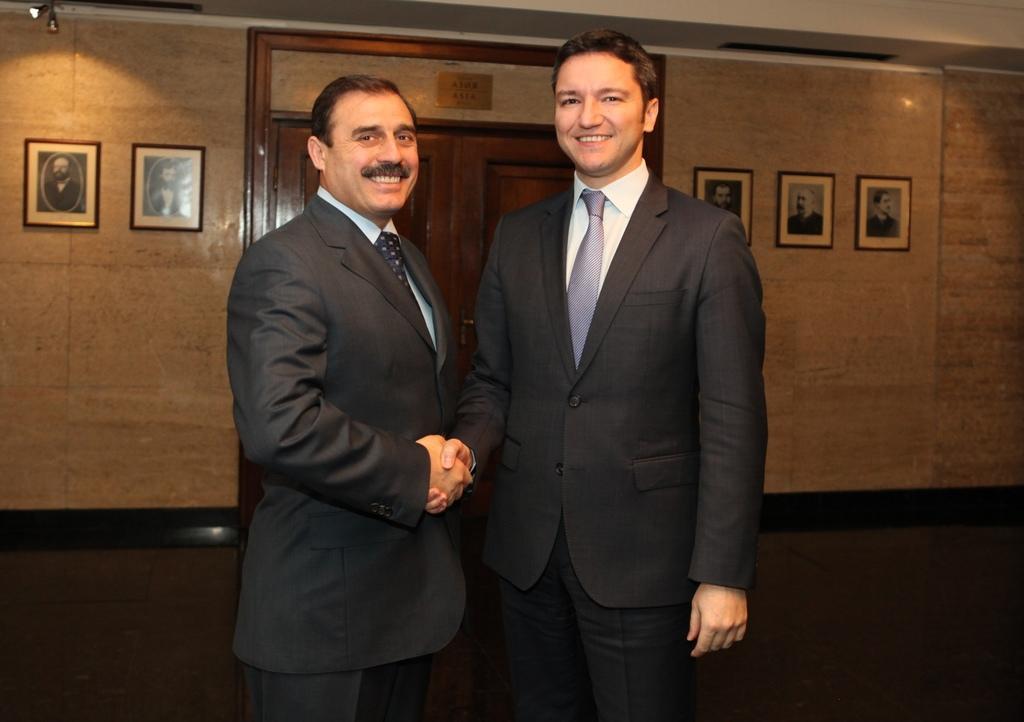Can you describe this image briefly? In this image I can see two persons wearing shirts, ties and black colored blazers are standing, smiling and shaking hands. In the background I can see the brown colored wall, the ceiling, few lights, few photo frames attached to the wall and the brown colored door. 